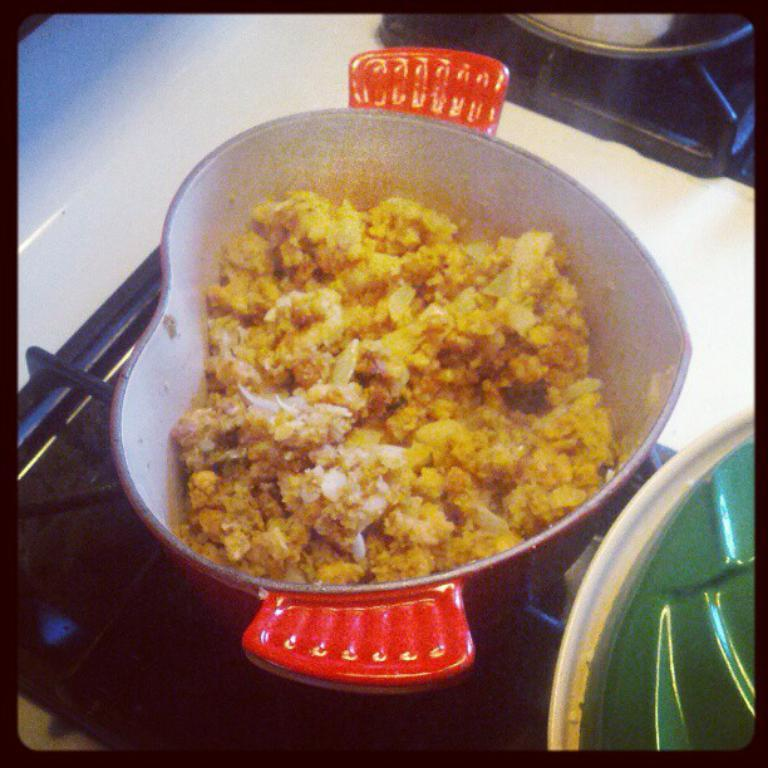What type of appliance is present in the image? There is a stove in the image. What is placed on the stove? There are bowls on the stove. What is inside one of the bowls? There is food in one of the bowls. What colors can be seen on the stove? The stove has a white and black color. What type of alarm can be heard going off in the image? There is no alarm present or audible in the image. What songs can be heard playing in the background of the image? There is no music or songs present in the image. 